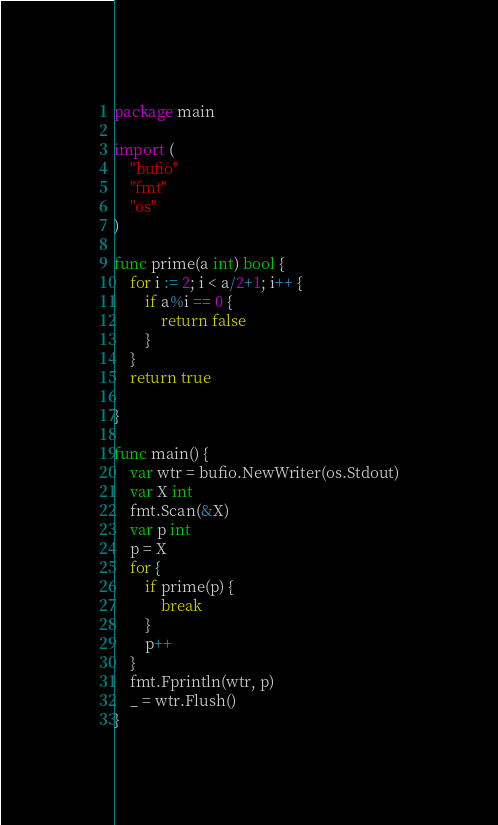Convert code to text. <code><loc_0><loc_0><loc_500><loc_500><_Go_>package main

import (
	"bufio"
	"fmt"
	"os"
)

func prime(a int) bool {
	for i := 2; i < a/2+1; i++ {
		if a%i == 0 {
			return false
		}
	}
	return true

}

func main() {
	var wtr = bufio.NewWriter(os.Stdout)
	var X int
	fmt.Scan(&X)
	var p int
	p = X
	for {
		if prime(p) {
			break
		}
		p++
	}
	fmt.Fprintln(wtr, p)
	_ = wtr.Flush()
}
</code> 